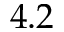Convert formula to latex. <formula><loc_0><loc_0><loc_500><loc_500>4 . 2</formula> 